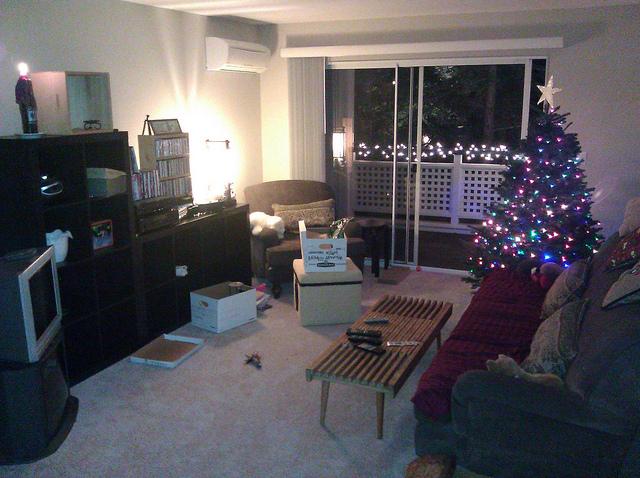What season is this?
Give a very brief answer. Christmas. Are there flowers on the table?
Quick response, please. No. Is there an ac unit on this room?
Answer briefly. Yes. What holiday is being celebrated?
Concise answer only. Christmas. What is laying on the floor?
Keep it brief. Box. How many lamps are in the picture?
Concise answer only. 2. What is shining through the window?
Short answer required. Lights. 